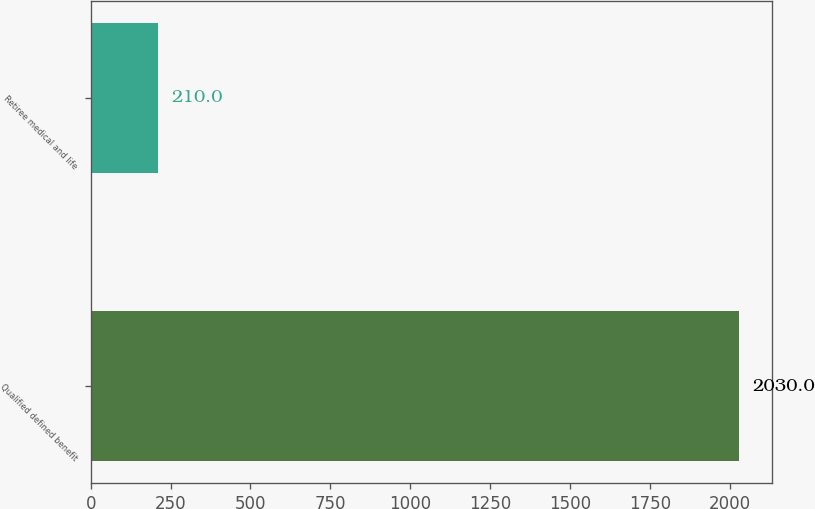Convert chart to OTSL. <chart><loc_0><loc_0><loc_500><loc_500><bar_chart><fcel>Qualified defined benefit<fcel>Retiree medical and life<nl><fcel>2030<fcel>210<nl></chart> 